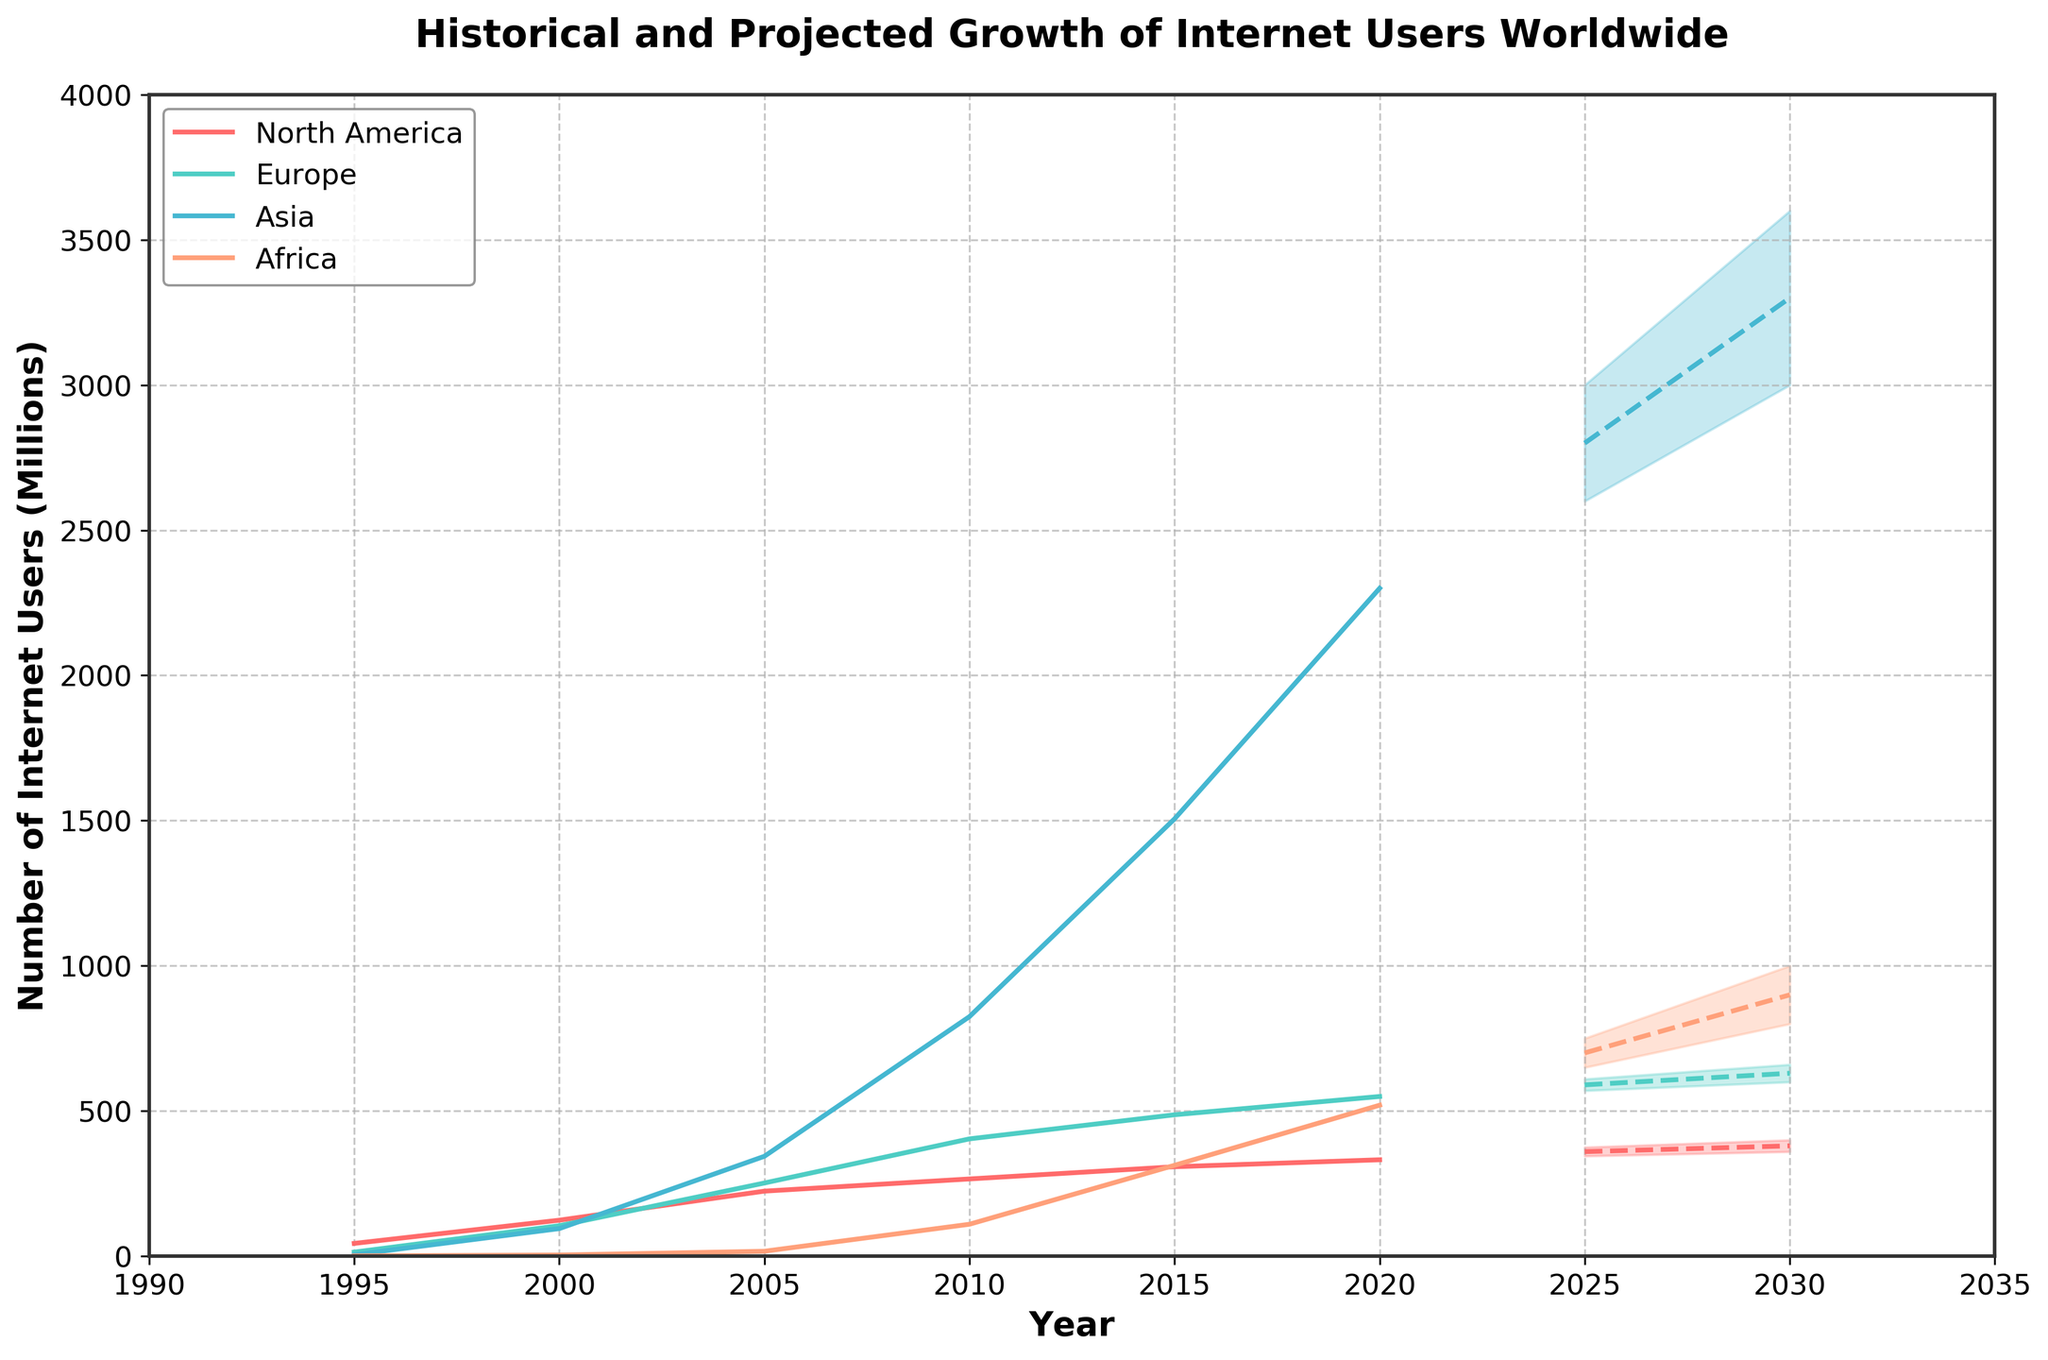What is the title of the chart? The title of the chart is displayed at the top of the figure. It reads "Historical and Projected Growth of Internet Users Worldwide"
Answer: Historical and Projected Growth of Internet Users Worldwide Which region had the highest number of internet users in 2010? By observing the plotted lines for each region, we can see that Asia had the highest number of internet users in 2010 based on the peak of the actual data marked for each region.
Answer: Asia What are the projected internet users in North America for 2030 according to the medium estimate? The chart provides projections, marked by dashed lines, for various regions. By looking at the projection for North America, the medium estimate for 2030 is around 380 million users.
Answer: 380 million users How does the number of internet users in Africa in 2025 compare to 2030 according to the medium projections? According to the medium projections, Africa's internet users rise from 700 million in 2025 to 900 million in 2030. So, there is an increase of 200 million users over these five years.
Answer: Increase by 200 million users In which decade did Asia see the most dramatic increase in internet users? To identify the decade with the most dramatic increase in internet users, observe the slope of the actual data lines. Asia saw the most dramatic increase between 2000 and 2010.
Answer: 2000-2010 What are the projected ranges (low to high) of internet users in Europe for 2025? The range between the lowest and highest projected numbers is visualized by the shaded area for the year 2025 in Europe, which shows a range from 570 million to 610 million users.
Answer: 570 to 610 million users Which region had the slowest growth in internet users from 1995 to 2020? By observing the lines representing actual data from 1995 to 2020, the steepness of the line for North America is the least, indicating the slowest growth.
Answer: North America What is the projected growth of internet users in Asia from 2020 to 2030 according to the medium projection? The medium projection shows an increase from 2800 million users in 2025 to 3300 million users in 2030. So, the projected growth is 500 million users.
Answer: 500 million users By how much did the number of internet users in North America increase from 1995 to 2000? To compute the increase, subtract the number of users in 1995 from the number in 2000. That is 124 million minus 44 million, resulting in an increase of 80 million users.
Answer: 80 million users 